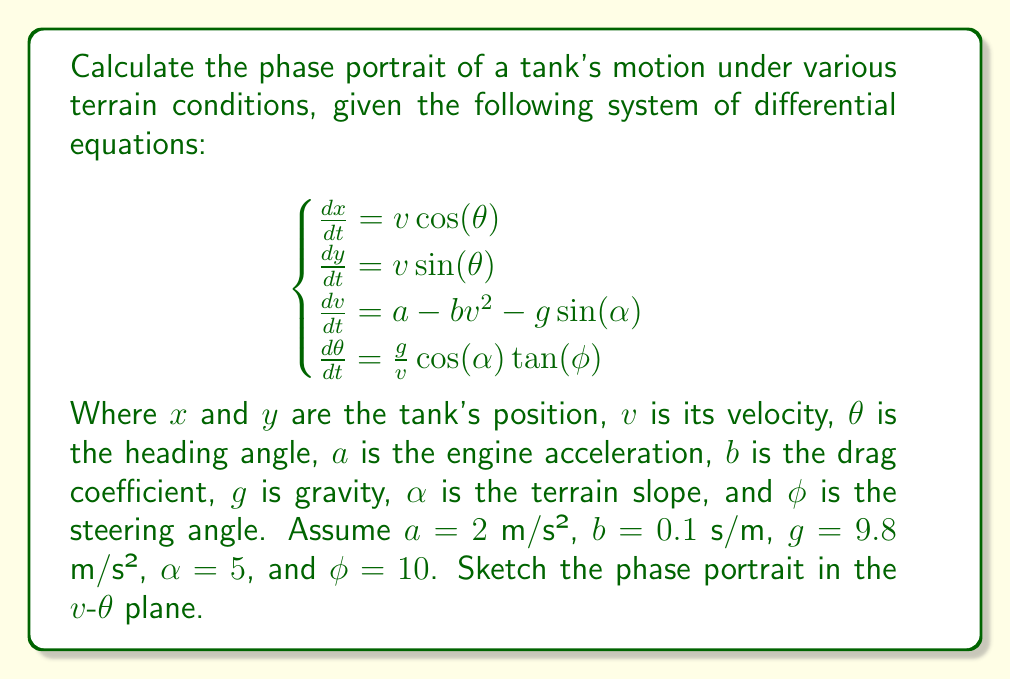Can you answer this question? To calculate the phase portrait, we'll follow these steps:

1) First, we're interested in the $v$-$\theta$ plane, so we'll focus on the last two equations:

   $$\frac{dv}{dt} = a - bv^2 - g\sin(\alpha)$$
   $$\frac{d\theta}{dt} = \frac{g}{v}\cos(\alpha)\tan(\phi)$$

2) Substitute the given values:
   $a = 2$ m/s², $b = 0.1$ s/m, $g = 9.8$ m/s², $\alpha = 5°$, $\phi = 10°$

3) Calculate $\sin(5°) = 0.0872$ and $\cos(5°) = 0.9962$

4) The equations become:
   $$\frac{dv}{dt} = 2 - 0.1v^2 - 9.8 \cdot 0.0872 = 2 - 0.1v^2 - 0.8546$$
   $$\frac{d\theta}{dt} = \frac{9.8 \cdot 0.9962 \cdot \tan(10°)}{v} = \frac{1.7241}{v}$$

5) To find equilibrium points, set both equations to zero:
   $2 - 0.1v^2 - 0.8546 = 0$
   $v^2 = 11.4454$
   $v = \pm 3.3830$ m/s (but we'll only consider the positive value)

   The $\theta$ equation doesn't have an equilibrium point for finite $v$.

6) The nullclines are:
   $v$-nullcline: $v = 3.3830$ m/s
   $\theta$-nullcline: doesn't exist for finite $v$

7) Analyze the vector field:
   - For $v < 3.3830$, $\frac{dv}{dt} > 0$, so $v$ increases
   - For $v > 3.3830$, $\frac{dv}{dt} < 0$, so $v$ decreases
   - $\frac{d\theta}{dt}$ is always positive, so $\theta$ always increases

8) Sketch the phase portrait:
   - Draw a vertical line at $v = 3.3830$
   - Draw arrows pointing right for $v < 3.3830$ and left for $v > 3.3830$
   - Draw arrows pointing up everywhere
   - The resulting trajectories will curve towards the $v$-nullcline and then move upward along it

[asy]
import graph;
size(200,200);
xaxis("v",Arrow);
yaxis("θ",Arrow);

real f(real v) {return 2 - 0.1*v^2 - 0.8546;}
real g(real v) {return 1.7241/v;}

for(real x=0; x<=5; x+=0.5)
  for(real y=0; y<=5; y+=0.5) {
    draw((x,y)--(x+0.2*f(x),y+0.2*g(x)),Arrow);
  }

draw((3.383,0)--(3.383,5),blue);
label("v-nullcline",(3.383,5),E);
</asy>
Answer: Phase portrait shows trajectories converging to $v = 3.3830$ m/s with $\theta$ continuously increasing. 